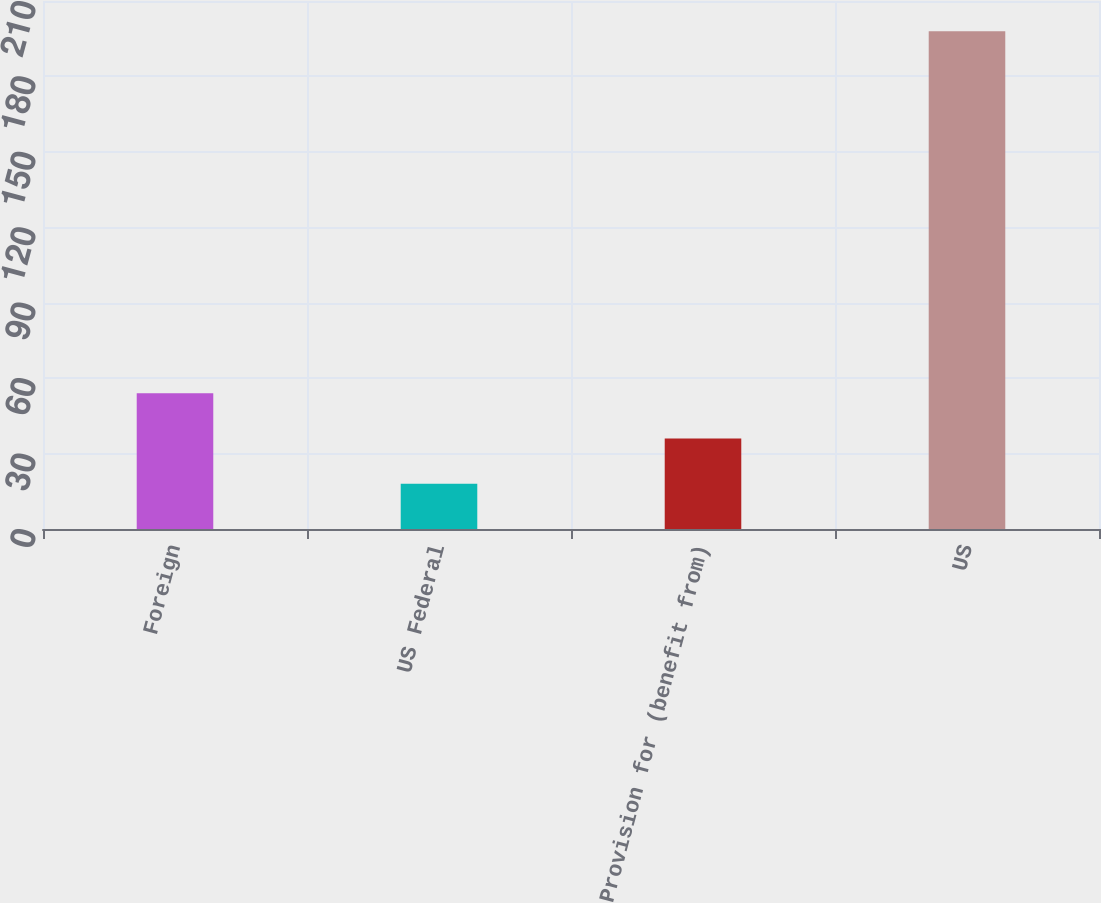Convert chart to OTSL. <chart><loc_0><loc_0><loc_500><loc_500><bar_chart><fcel>Foreign<fcel>US Federal<fcel>Provision for (benefit from)<fcel>US<nl><fcel>54<fcel>18<fcel>36<fcel>198<nl></chart> 